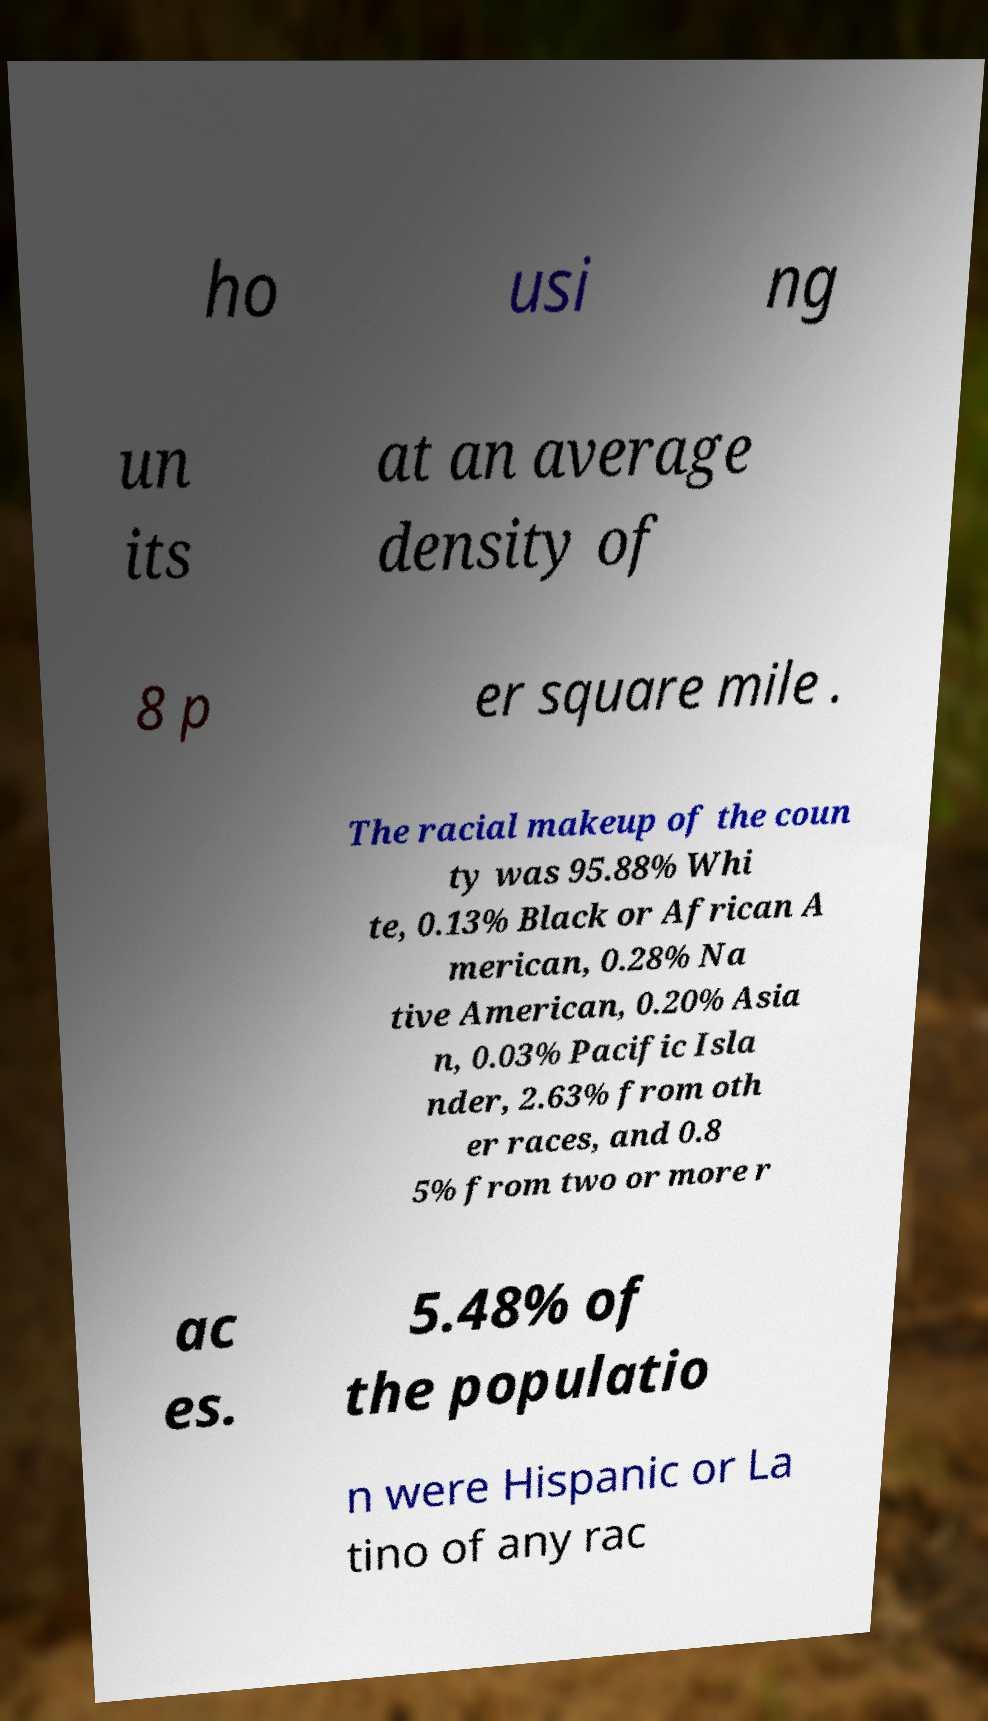Please read and relay the text visible in this image. What does it say? ho usi ng un its at an average density of 8 p er square mile . The racial makeup of the coun ty was 95.88% Whi te, 0.13% Black or African A merican, 0.28% Na tive American, 0.20% Asia n, 0.03% Pacific Isla nder, 2.63% from oth er races, and 0.8 5% from two or more r ac es. 5.48% of the populatio n were Hispanic or La tino of any rac 